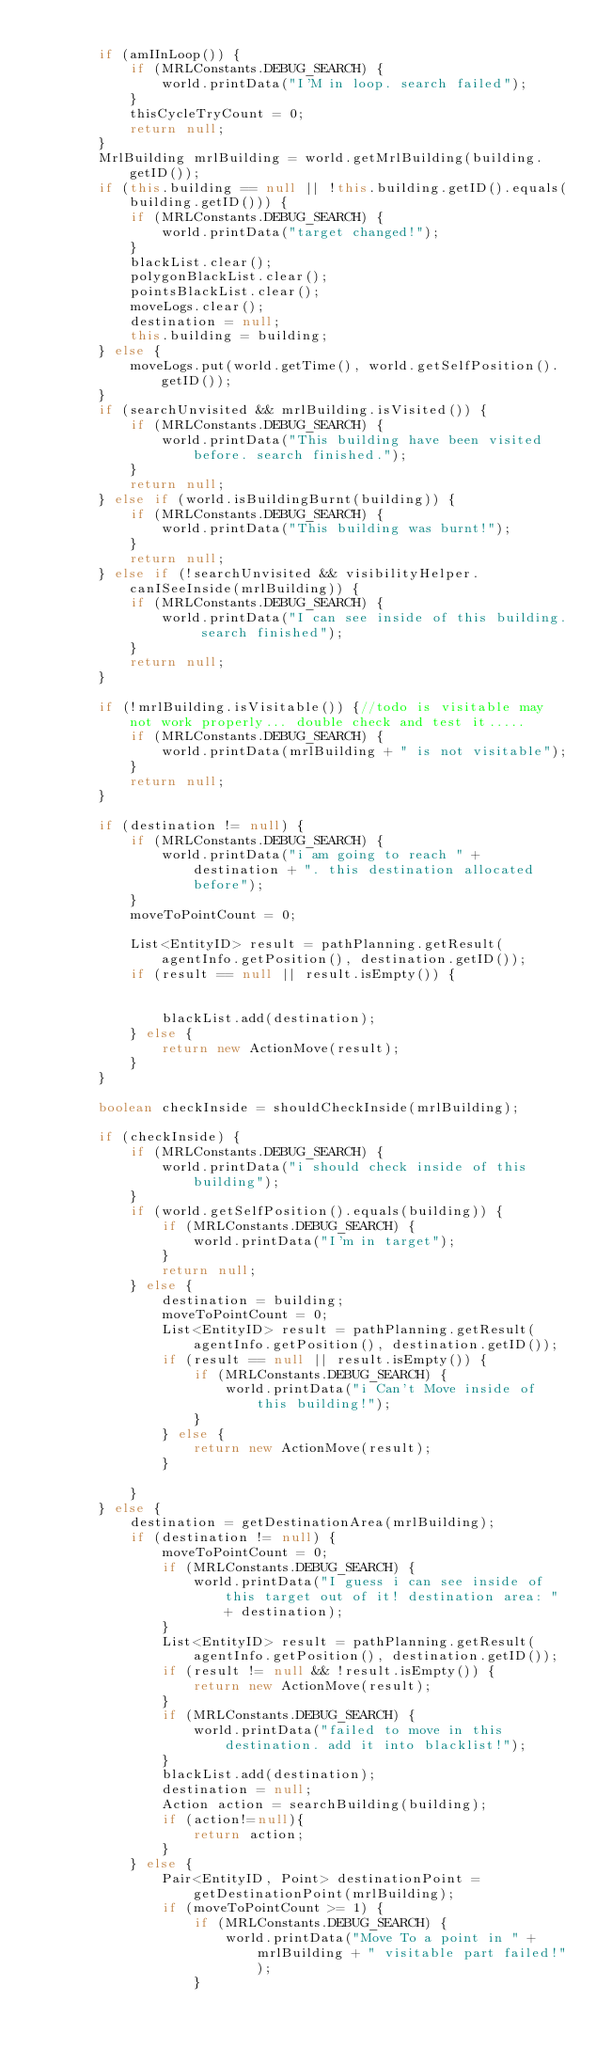<code> <loc_0><loc_0><loc_500><loc_500><_Java_>
        if (amIInLoop()) {
            if (MRLConstants.DEBUG_SEARCH) {
                world.printData("I'M in loop. search failed");
            }
            thisCycleTryCount = 0;
            return null;
        }
        MrlBuilding mrlBuilding = world.getMrlBuilding(building.getID());
        if (this.building == null || !this.building.getID().equals(building.getID())) {
            if (MRLConstants.DEBUG_SEARCH) {
                world.printData("target changed!");
            }
            blackList.clear();
            polygonBlackList.clear();
            pointsBlackList.clear();
            moveLogs.clear();
            destination = null;
            this.building = building;
        } else {
            moveLogs.put(world.getTime(), world.getSelfPosition().getID());
        }
        if (searchUnvisited && mrlBuilding.isVisited()) {
            if (MRLConstants.DEBUG_SEARCH) {
                world.printData("This building have been visited before. search finished.");
            }
            return null;
        } else if (world.isBuildingBurnt(building)) {
            if (MRLConstants.DEBUG_SEARCH) {
                world.printData("This building was burnt!");
            }
            return null;
        } else if (!searchUnvisited && visibilityHelper.canISeeInside(mrlBuilding)) {
            if (MRLConstants.DEBUG_SEARCH) {
                world.printData("I can see inside of this building. search finished");
            }
            return null;
        }

        if (!mrlBuilding.isVisitable()) {//todo is visitable may not work properly... double check and test it.....
            if (MRLConstants.DEBUG_SEARCH) {
                world.printData(mrlBuilding + " is not visitable");
            }
            return null;
        }

        if (destination != null) {
            if (MRLConstants.DEBUG_SEARCH) {
                world.printData("i am going to reach " + destination + ". this destination allocated before");
            }
            moveToPointCount = 0;

            List<EntityID> result = pathPlanning.getResult(agentInfo.getPosition(), destination.getID());
            if (result == null || result.isEmpty()) {


                blackList.add(destination);
            } else {
                return new ActionMove(result);
            }
        }

        boolean checkInside = shouldCheckInside(mrlBuilding);

        if (checkInside) {
            if (MRLConstants.DEBUG_SEARCH) {
                world.printData("i should check inside of this building");
            }
            if (world.getSelfPosition().equals(building)) {
                if (MRLConstants.DEBUG_SEARCH) {
                    world.printData("I'm in target");
                }
                return null;
            } else {
                destination = building;
                moveToPointCount = 0;
                List<EntityID> result = pathPlanning.getResult(agentInfo.getPosition(), destination.getID());
                if (result == null || result.isEmpty()) {
                    if (MRLConstants.DEBUG_SEARCH) {
                        world.printData("i Can't Move inside of this building!");
                    }
                } else {
                    return new ActionMove(result);
                }

            }
        } else {
            destination = getDestinationArea(mrlBuilding);
            if (destination != null) {
                moveToPointCount = 0;
                if (MRLConstants.DEBUG_SEARCH) {
                    world.printData("I guess i can see inside of this target out of it! destination area: " + destination);
                }
                List<EntityID> result = pathPlanning.getResult(agentInfo.getPosition(), destination.getID());
                if (result != null && !result.isEmpty()) {
                    return new ActionMove(result);
                }
                if (MRLConstants.DEBUG_SEARCH) {
                    world.printData("failed to move in this destination. add it into blacklist!");
                }
                blackList.add(destination);
                destination = null;
                Action action = searchBuilding(building);
                if (action!=null){
                    return action;
                }
            } else {
                Pair<EntityID, Point> destinationPoint = getDestinationPoint(mrlBuilding);
                if (moveToPointCount >= 1) {
                    if (MRLConstants.DEBUG_SEARCH) {
                        world.printData("Move To a point in " + mrlBuilding + " visitable part failed!");
                    }</code> 